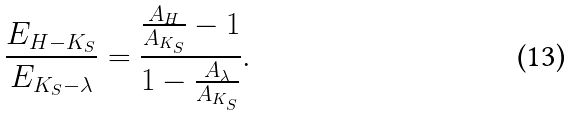Convert formula to latex. <formula><loc_0><loc_0><loc_500><loc_500>\frac { E _ { H - K _ { S } } } { E _ { K _ { S } - \lambda } } = \frac { \frac { A _ { H } } { A _ { K _ { S } } } - 1 } { 1 - \frac { A _ { \lambda } } { A _ { K _ { S } } } } .</formula> 